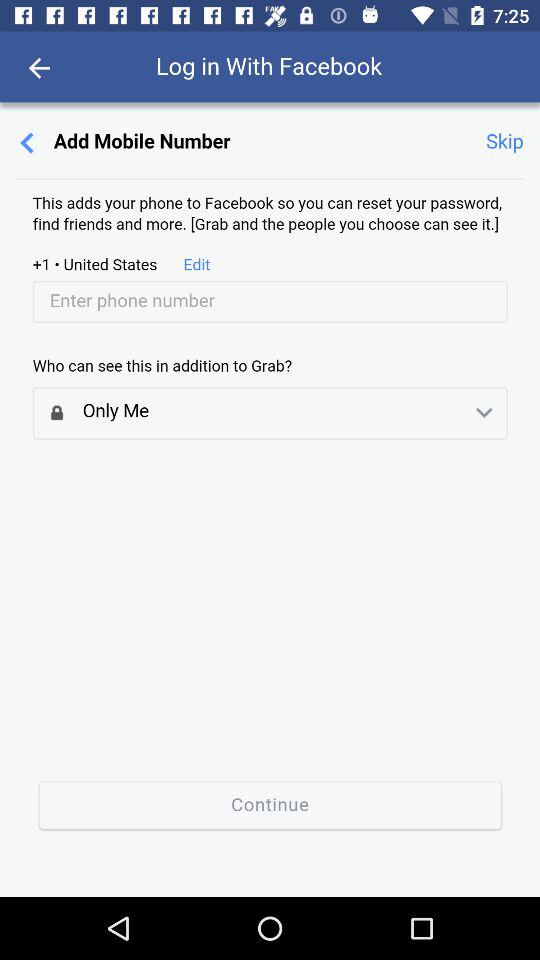Through what application can we log in? You can log in through "Facebook". 